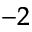<formula> <loc_0><loc_0><loc_500><loc_500>^ { - 2 }</formula> 